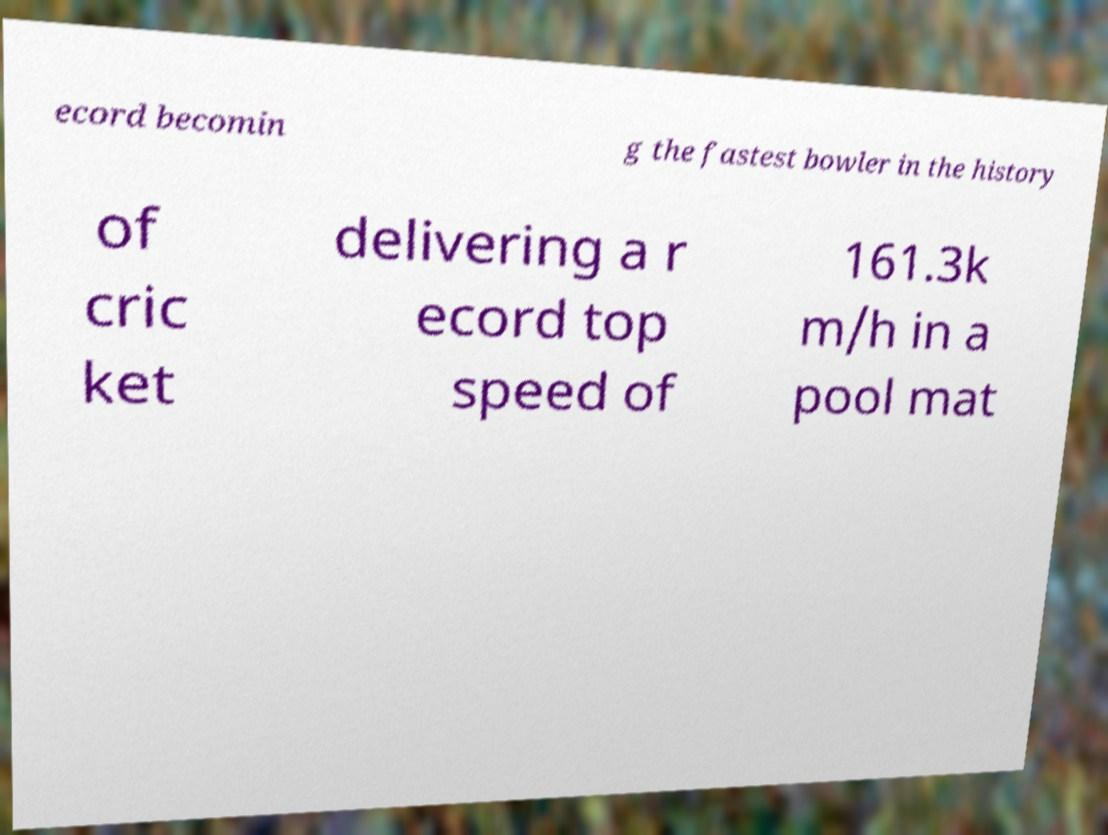Can you read and provide the text displayed in the image?This photo seems to have some interesting text. Can you extract and type it out for me? ecord becomin g the fastest bowler in the history of cric ket delivering a r ecord top speed of 161.3k m/h in a pool mat 